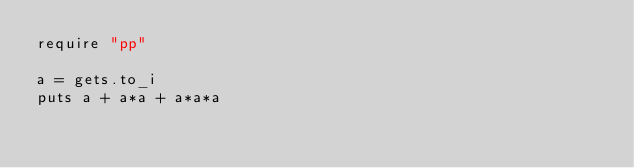Convert code to text. <code><loc_0><loc_0><loc_500><loc_500><_Ruby_>require "pp"

a = gets.to_i
puts a + a*a + a*a*a</code> 